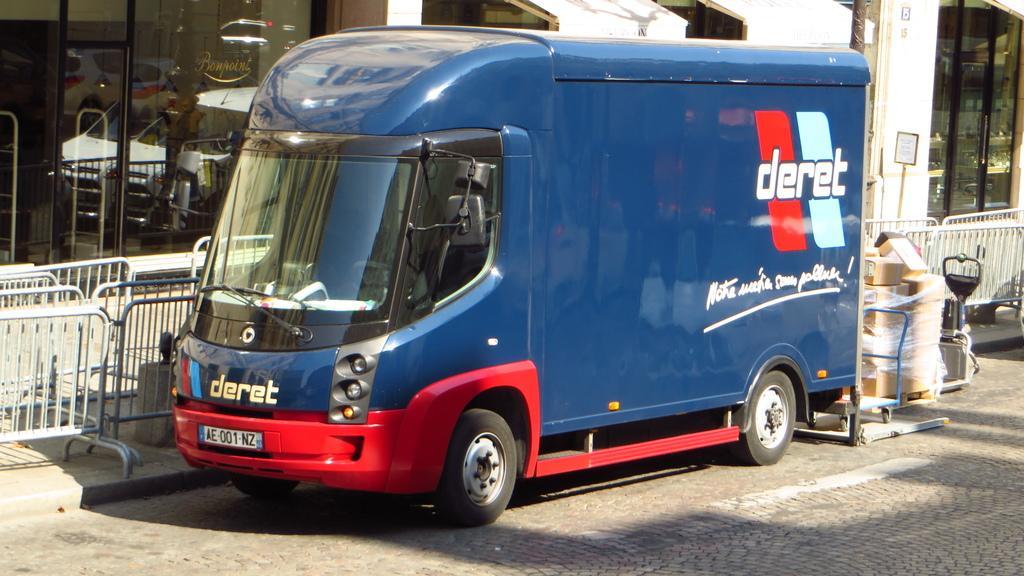Describe this image in one or two sentences. In the foreground I can see a truck on the road and carton boxes. In the background I can see a fence, buildings and a board. This image is taken during a day near the road. 